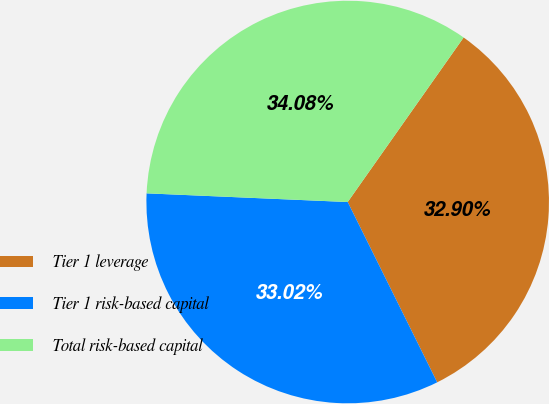<chart> <loc_0><loc_0><loc_500><loc_500><pie_chart><fcel>Tier 1 leverage<fcel>Tier 1 risk-based capital<fcel>Total risk-based capital<nl><fcel>32.9%<fcel>33.02%<fcel>34.08%<nl></chart> 